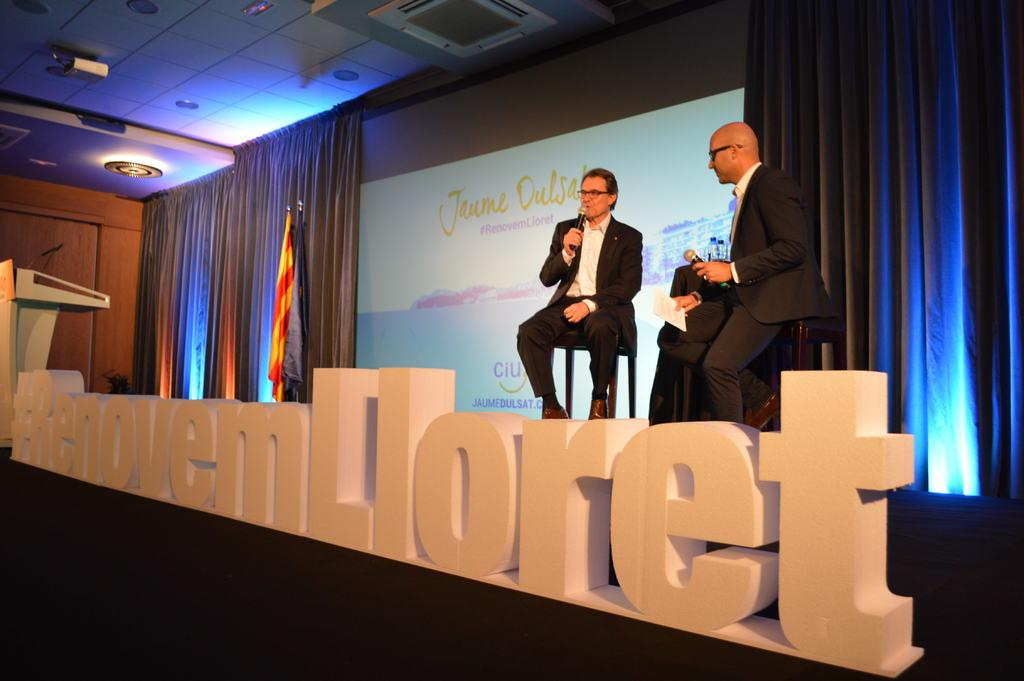<image>
Give a short and clear explanation of the subsequent image. two men at a convention speaking with the text #RenovemLloret. 